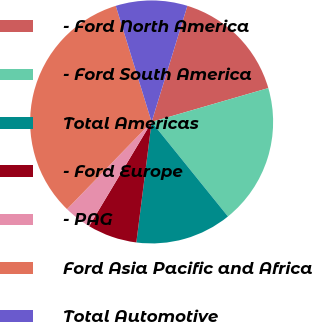Convert chart to OTSL. <chart><loc_0><loc_0><loc_500><loc_500><pie_chart><fcel>- Ford North America<fcel>- Ford South America<fcel>Total Americas<fcel>- Ford Europe<fcel>- PAG<fcel>Ford Asia Pacific and Africa<fcel>Total Automotive<nl><fcel>15.75%<fcel>18.68%<fcel>12.82%<fcel>6.59%<fcel>3.66%<fcel>32.97%<fcel>9.52%<nl></chart> 